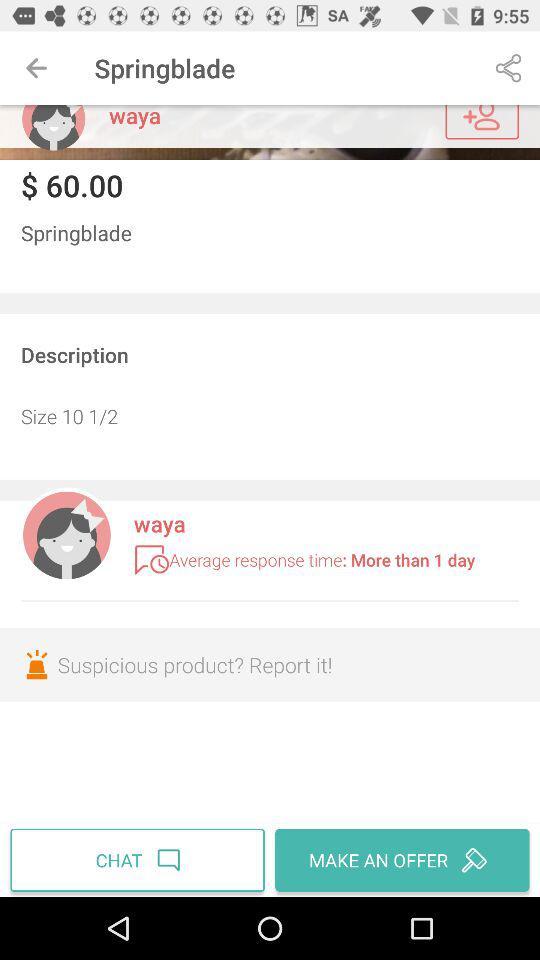What is the name of the user? The user name is Waya. 